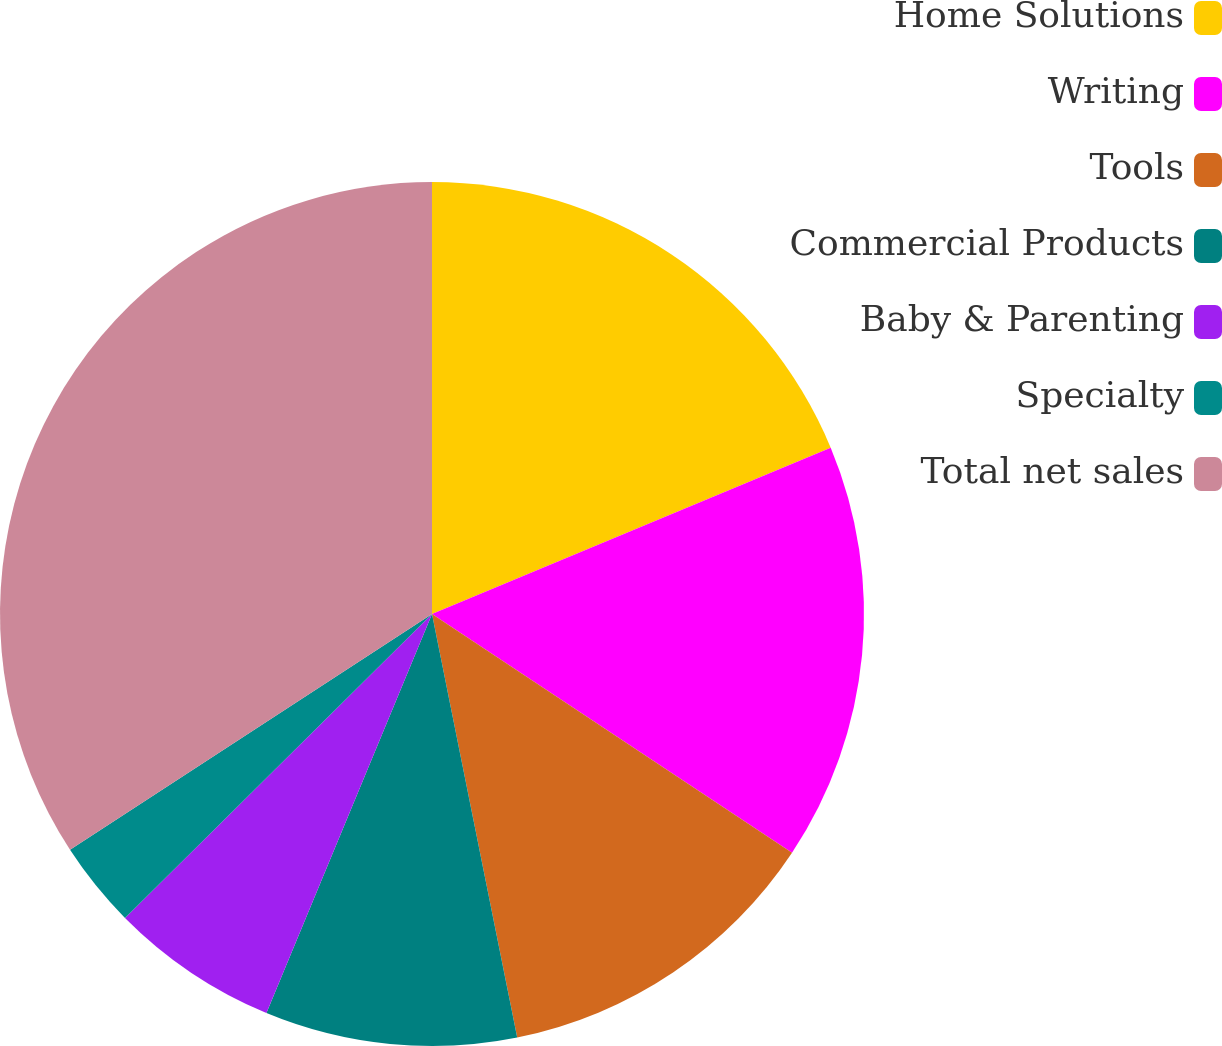Convert chart to OTSL. <chart><loc_0><loc_0><loc_500><loc_500><pie_chart><fcel>Home Solutions<fcel>Writing<fcel>Tools<fcel>Commercial Products<fcel>Baby & Parenting<fcel>Specialty<fcel>Total net sales<nl><fcel>18.71%<fcel>15.61%<fcel>12.52%<fcel>9.42%<fcel>6.32%<fcel>3.23%<fcel>34.19%<nl></chart> 